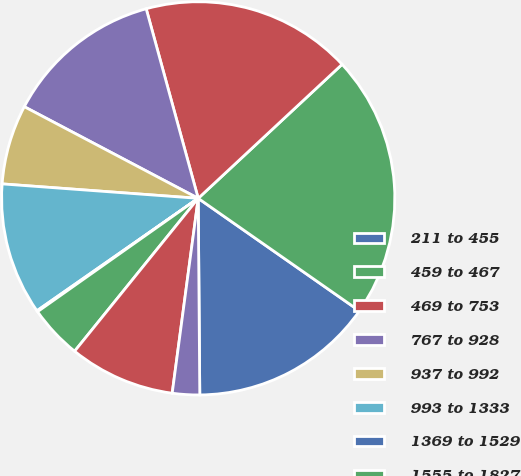Convert chart. <chart><loc_0><loc_0><loc_500><loc_500><pie_chart><fcel>211 to 455<fcel>459 to 467<fcel>469 to 753<fcel>767 to 928<fcel>937 to 992<fcel>993 to 1333<fcel>1369 to 1529<fcel>1555 to 1827<fcel>1841 to 1841<fcel>1843 to 2216<nl><fcel>15.17%<fcel>21.64%<fcel>17.33%<fcel>13.02%<fcel>6.55%<fcel>10.86%<fcel>0.09%<fcel>4.4%<fcel>8.71%<fcel>2.24%<nl></chart> 